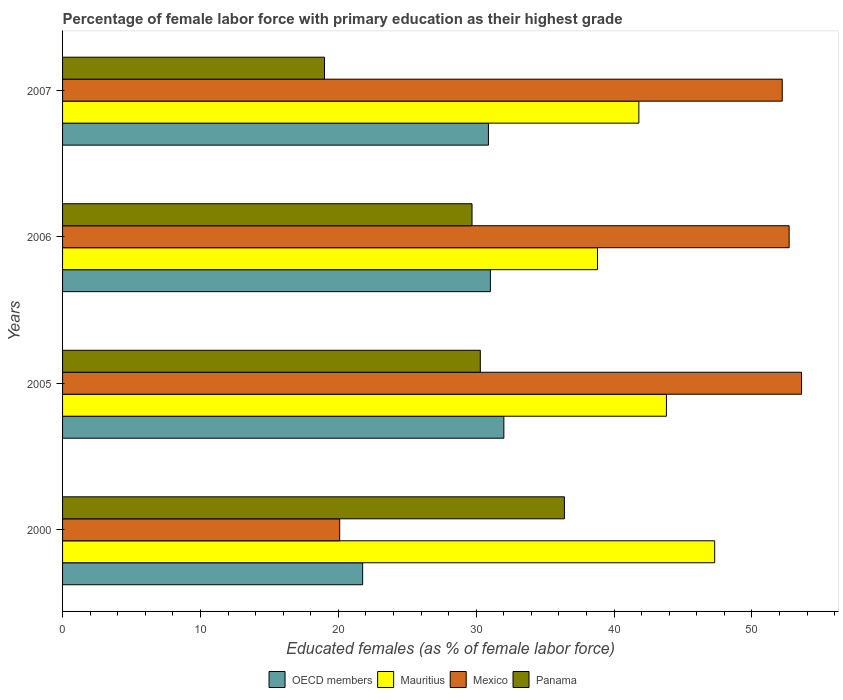How many bars are there on the 2nd tick from the top?
Your answer should be compact. 4. How many bars are there on the 1st tick from the bottom?
Provide a succinct answer. 4. What is the label of the 3rd group of bars from the top?
Ensure brevity in your answer.  2005. In how many cases, is the number of bars for a given year not equal to the number of legend labels?
Make the answer very short. 0. What is the percentage of female labor force with primary education in Mexico in 2005?
Offer a terse response. 53.6. Across all years, what is the maximum percentage of female labor force with primary education in Panama?
Keep it short and to the point. 36.4. Across all years, what is the minimum percentage of female labor force with primary education in Panama?
Keep it short and to the point. 19. In which year was the percentage of female labor force with primary education in Panama minimum?
Make the answer very short. 2007. What is the total percentage of female labor force with primary education in Mexico in the graph?
Ensure brevity in your answer.  178.6. What is the difference between the percentage of female labor force with primary education in Panama in 2005 and that in 2007?
Offer a very short reply. 11.3. What is the difference between the percentage of female labor force with primary education in OECD members in 2006 and the percentage of female labor force with primary education in Panama in 2007?
Ensure brevity in your answer.  12.03. What is the average percentage of female labor force with primary education in Panama per year?
Your answer should be very brief. 28.85. In the year 2005, what is the difference between the percentage of female labor force with primary education in OECD members and percentage of female labor force with primary education in Mauritius?
Ensure brevity in your answer.  -11.79. What is the ratio of the percentage of female labor force with primary education in Mauritius in 2006 to that in 2007?
Give a very brief answer. 0.93. Is the percentage of female labor force with primary education in Mexico in 2006 less than that in 2007?
Make the answer very short. No. Is the difference between the percentage of female labor force with primary education in OECD members in 2006 and 2007 greater than the difference between the percentage of female labor force with primary education in Mauritius in 2006 and 2007?
Your answer should be compact. Yes. What is the difference between the highest and the second highest percentage of female labor force with primary education in OECD members?
Your answer should be compact. 0.98. What is the difference between the highest and the lowest percentage of female labor force with primary education in Panama?
Offer a terse response. 17.4. Is the sum of the percentage of female labor force with primary education in OECD members in 2000 and 2007 greater than the maximum percentage of female labor force with primary education in Mexico across all years?
Provide a short and direct response. No. Is it the case that in every year, the sum of the percentage of female labor force with primary education in Panama and percentage of female labor force with primary education in OECD members is greater than the sum of percentage of female labor force with primary education in Mexico and percentage of female labor force with primary education in Mauritius?
Provide a succinct answer. No. What does the 2nd bar from the bottom in 2007 represents?
Give a very brief answer. Mauritius. How many bars are there?
Your answer should be very brief. 16. Are all the bars in the graph horizontal?
Your answer should be very brief. Yes. What is the difference between two consecutive major ticks on the X-axis?
Give a very brief answer. 10. Does the graph contain grids?
Your answer should be very brief. No. What is the title of the graph?
Offer a terse response. Percentage of female labor force with primary education as their highest grade. Does "Congo (Republic)" appear as one of the legend labels in the graph?
Your answer should be very brief. No. What is the label or title of the X-axis?
Offer a very short reply. Educated females (as % of female labor force). What is the label or title of the Y-axis?
Your answer should be compact. Years. What is the Educated females (as % of female labor force) of OECD members in 2000?
Provide a succinct answer. 21.77. What is the Educated females (as % of female labor force) in Mauritius in 2000?
Offer a very short reply. 47.3. What is the Educated females (as % of female labor force) of Mexico in 2000?
Your answer should be very brief. 20.1. What is the Educated females (as % of female labor force) in Panama in 2000?
Offer a very short reply. 36.4. What is the Educated females (as % of female labor force) in OECD members in 2005?
Keep it short and to the point. 32.01. What is the Educated females (as % of female labor force) of Mauritius in 2005?
Your response must be concise. 43.8. What is the Educated females (as % of female labor force) of Mexico in 2005?
Your response must be concise. 53.6. What is the Educated females (as % of female labor force) in Panama in 2005?
Give a very brief answer. 30.3. What is the Educated females (as % of female labor force) in OECD members in 2006?
Your response must be concise. 31.03. What is the Educated females (as % of female labor force) of Mauritius in 2006?
Provide a succinct answer. 38.8. What is the Educated females (as % of female labor force) of Mexico in 2006?
Your answer should be very brief. 52.7. What is the Educated females (as % of female labor force) in Panama in 2006?
Your answer should be very brief. 29.7. What is the Educated females (as % of female labor force) in OECD members in 2007?
Make the answer very short. 30.89. What is the Educated females (as % of female labor force) in Mauritius in 2007?
Make the answer very short. 41.8. What is the Educated females (as % of female labor force) in Mexico in 2007?
Your answer should be very brief. 52.2. What is the Educated females (as % of female labor force) of Panama in 2007?
Provide a succinct answer. 19. Across all years, what is the maximum Educated females (as % of female labor force) of OECD members?
Ensure brevity in your answer.  32.01. Across all years, what is the maximum Educated females (as % of female labor force) of Mauritius?
Offer a terse response. 47.3. Across all years, what is the maximum Educated females (as % of female labor force) in Mexico?
Offer a terse response. 53.6. Across all years, what is the maximum Educated females (as % of female labor force) in Panama?
Give a very brief answer. 36.4. Across all years, what is the minimum Educated females (as % of female labor force) of OECD members?
Your answer should be compact. 21.77. Across all years, what is the minimum Educated females (as % of female labor force) in Mauritius?
Ensure brevity in your answer.  38.8. Across all years, what is the minimum Educated females (as % of female labor force) in Mexico?
Provide a succinct answer. 20.1. What is the total Educated females (as % of female labor force) in OECD members in the graph?
Make the answer very short. 115.69. What is the total Educated females (as % of female labor force) in Mauritius in the graph?
Keep it short and to the point. 171.7. What is the total Educated females (as % of female labor force) of Mexico in the graph?
Your answer should be compact. 178.6. What is the total Educated females (as % of female labor force) in Panama in the graph?
Keep it short and to the point. 115.4. What is the difference between the Educated females (as % of female labor force) of OECD members in 2000 and that in 2005?
Your response must be concise. -10.24. What is the difference between the Educated females (as % of female labor force) of Mexico in 2000 and that in 2005?
Give a very brief answer. -33.5. What is the difference between the Educated females (as % of female labor force) in OECD members in 2000 and that in 2006?
Ensure brevity in your answer.  -9.26. What is the difference between the Educated females (as % of female labor force) in Mauritius in 2000 and that in 2006?
Make the answer very short. 8.5. What is the difference between the Educated females (as % of female labor force) in Mexico in 2000 and that in 2006?
Provide a short and direct response. -32.6. What is the difference between the Educated females (as % of female labor force) of Panama in 2000 and that in 2006?
Give a very brief answer. 6.7. What is the difference between the Educated females (as % of female labor force) of OECD members in 2000 and that in 2007?
Offer a terse response. -9.12. What is the difference between the Educated females (as % of female labor force) of Mauritius in 2000 and that in 2007?
Make the answer very short. 5.5. What is the difference between the Educated females (as % of female labor force) of Mexico in 2000 and that in 2007?
Provide a succinct answer. -32.1. What is the difference between the Educated females (as % of female labor force) of Panama in 2000 and that in 2007?
Your response must be concise. 17.4. What is the difference between the Educated females (as % of female labor force) in OECD members in 2005 and that in 2006?
Keep it short and to the point. 0.98. What is the difference between the Educated females (as % of female labor force) of Mauritius in 2005 and that in 2006?
Provide a succinct answer. 5. What is the difference between the Educated females (as % of female labor force) in OECD members in 2005 and that in 2007?
Your answer should be compact. 1.12. What is the difference between the Educated females (as % of female labor force) of Mauritius in 2005 and that in 2007?
Offer a terse response. 2. What is the difference between the Educated females (as % of female labor force) in Panama in 2005 and that in 2007?
Your response must be concise. 11.3. What is the difference between the Educated females (as % of female labor force) of OECD members in 2006 and that in 2007?
Offer a terse response. 0.14. What is the difference between the Educated females (as % of female labor force) of OECD members in 2000 and the Educated females (as % of female labor force) of Mauritius in 2005?
Keep it short and to the point. -22.03. What is the difference between the Educated females (as % of female labor force) in OECD members in 2000 and the Educated females (as % of female labor force) in Mexico in 2005?
Offer a terse response. -31.83. What is the difference between the Educated females (as % of female labor force) in OECD members in 2000 and the Educated females (as % of female labor force) in Panama in 2005?
Offer a terse response. -8.53. What is the difference between the Educated females (as % of female labor force) of Mauritius in 2000 and the Educated females (as % of female labor force) of Mexico in 2005?
Your response must be concise. -6.3. What is the difference between the Educated females (as % of female labor force) of OECD members in 2000 and the Educated females (as % of female labor force) of Mauritius in 2006?
Offer a very short reply. -17.03. What is the difference between the Educated females (as % of female labor force) in OECD members in 2000 and the Educated females (as % of female labor force) in Mexico in 2006?
Offer a terse response. -30.93. What is the difference between the Educated females (as % of female labor force) in OECD members in 2000 and the Educated females (as % of female labor force) in Panama in 2006?
Your answer should be compact. -7.93. What is the difference between the Educated females (as % of female labor force) of Mauritius in 2000 and the Educated females (as % of female labor force) of Mexico in 2006?
Your answer should be compact. -5.4. What is the difference between the Educated females (as % of female labor force) of OECD members in 2000 and the Educated females (as % of female labor force) of Mauritius in 2007?
Provide a succinct answer. -20.03. What is the difference between the Educated females (as % of female labor force) in OECD members in 2000 and the Educated females (as % of female labor force) in Mexico in 2007?
Your answer should be very brief. -30.43. What is the difference between the Educated females (as % of female labor force) of OECD members in 2000 and the Educated females (as % of female labor force) of Panama in 2007?
Keep it short and to the point. 2.77. What is the difference between the Educated females (as % of female labor force) in Mauritius in 2000 and the Educated females (as % of female labor force) in Panama in 2007?
Give a very brief answer. 28.3. What is the difference between the Educated females (as % of female labor force) in Mexico in 2000 and the Educated females (as % of female labor force) in Panama in 2007?
Your answer should be very brief. 1.1. What is the difference between the Educated females (as % of female labor force) in OECD members in 2005 and the Educated females (as % of female labor force) in Mauritius in 2006?
Provide a succinct answer. -6.79. What is the difference between the Educated females (as % of female labor force) in OECD members in 2005 and the Educated females (as % of female labor force) in Mexico in 2006?
Offer a very short reply. -20.69. What is the difference between the Educated females (as % of female labor force) in OECD members in 2005 and the Educated females (as % of female labor force) in Panama in 2006?
Your response must be concise. 2.31. What is the difference between the Educated females (as % of female labor force) in Mauritius in 2005 and the Educated females (as % of female labor force) in Mexico in 2006?
Your answer should be very brief. -8.9. What is the difference between the Educated females (as % of female labor force) in Mexico in 2005 and the Educated females (as % of female labor force) in Panama in 2006?
Ensure brevity in your answer.  23.9. What is the difference between the Educated females (as % of female labor force) of OECD members in 2005 and the Educated females (as % of female labor force) of Mauritius in 2007?
Offer a terse response. -9.79. What is the difference between the Educated females (as % of female labor force) of OECD members in 2005 and the Educated females (as % of female labor force) of Mexico in 2007?
Offer a terse response. -20.19. What is the difference between the Educated females (as % of female labor force) of OECD members in 2005 and the Educated females (as % of female labor force) of Panama in 2007?
Offer a very short reply. 13.01. What is the difference between the Educated females (as % of female labor force) of Mauritius in 2005 and the Educated females (as % of female labor force) of Panama in 2007?
Offer a terse response. 24.8. What is the difference between the Educated females (as % of female labor force) of Mexico in 2005 and the Educated females (as % of female labor force) of Panama in 2007?
Give a very brief answer. 34.6. What is the difference between the Educated females (as % of female labor force) in OECD members in 2006 and the Educated females (as % of female labor force) in Mauritius in 2007?
Provide a short and direct response. -10.77. What is the difference between the Educated females (as % of female labor force) of OECD members in 2006 and the Educated females (as % of female labor force) of Mexico in 2007?
Your answer should be very brief. -21.17. What is the difference between the Educated females (as % of female labor force) of OECD members in 2006 and the Educated females (as % of female labor force) of Panama in 2007?
Give a very brief answer. 12.03. What is the difference between the Educated females (as % of female labor force) in Mauritius in 2006 and the Educated females (as % of female labor force) in Mexico in 2007?
Give a very brief answer. -13.4. What is the difference between the Educated females (as % of female labor force) in Mauritius in 2006 and the Educated females (as % of female labor force) in Panama in 2007?
Make the answer very short. 19.8. What is the difference between the Educated females (as % of female labor force) of Mexico in 2006 and the Educated females (as % of female labor force) of Panama in 2007?
Offer a terse response. 33.7. What is the average Educated females (as % of female labor force) in OECD members per year?
Keep it short and to the point. 28.92. What is the average Educated females (as % of female labor force) of Mauritius per year?
Your answer should be compact. 42.92. What is the average Educated females (as % of female labor force) of Mexico per year?
Offer a very short reply. 44.65. What is the average Educated females (as % of female labor force) in Panama per year?
Offer a terse response. 28.85. In the year 2000, what is the difference between the Educated females (as % of female labor force) of OECD members and Educated females (as % of female labor force) of Mauritius?
Ensure brevity in your answer.  -25.53. In the year 2000, what is the difference between the Educated females (as % of female labor force) of OECD members and Educated females (as % of female labor force) of Mexico?
Provide a short and direct response. 1.67. In the year 2000, what is the difference between the Educated females (as % of female labor force) of OECD members and Educated females (as % of female labor force) of Panama?
Offer a terse response. -14.63. In the year 2000, what is the difference between the Educated females (as % of female labor force) in Mauritius and Educated females (as % of female labor force) in Mexico?
Make the answer very short. 27.2. In the year 2000, what is the difference between the Educated females (as % of female labor force) in Mexico and Educated females (as % of female labor force) in Panama?
Offer a very short reply. -16.3. In the year 2005, what is the difference between the Educated females (as % of female labor force) of OECD members and Educated females (as % of female labor force) of Mauritius?
Provide a short and direct response. -11.79. In the year 2005, what is the difference between the Educated females (as % of female labor force) in OECD members and Educated females (as % of female labor force) in Mexico?
Offer a terse response. -21.59. In the year 2005, what is the difference between the Educated females (as % of female labor force) in OECD members and Educated females (as % of female labor force) in Panama?
Keep it short and to the point. 1.71. In the year 2005, what is the difference between the Educated females (as % of female labor force) of Mauritius and Educated females (as % of female labor force) of Panama?
Provide a succinct answer. 13.5. In the year 2005, what is the difference between the Educated females (as % of female labor force) in Mexico and Educated females (as % of female labor force) in Panama?
Make the answer very short. 23.3. In the year 2006, what is the difference between the Educated females (as % of female labor force) in OECD members and Educated females (as % of female labor force) in Mauritius?
Your answer should be compact. -7.77. In the year 2006, what is the difference between the Educated females (as % of female labor force) in OECD members and Educated females (as % of female labor force) in Mexico?
Make the answer very short. -21.67. In the year 2006, what is the difference between the Educated females (as % of female labor force) in OECD members and Educated females (as % of female labor force) in Panama?
Make the answer very short. 1.33. In the year 2006, what is the difference between the Educated females (as % of female labor force) in Mauritius and Educated females (as % of female labor force) in Mexico?
Your response must be concise. -13.9. In the year 2006, what is the difference between the Educated females (as % of female labor force) in Mauritius and Educated females (as % of female labor force) in Panama?
Give a very brief answer. 9.1. In the year 2007, what is the difference between the Educated females (as % of female labor force) of OECD members and Educated females (as % of female labor force) of Mauritius?
Provide a succinct answer. -10.91. In the year 2007, what is the difference between the Educated females (as % of female labor force) of OECD members and Educated females (as % of female labor force) of Mexico?
Ensure brevity in your answer.  -21.31. In the year 2007, what is the difference between the Educated females (as % of female labor force) in OECD members and Educated females (as % of female labor force) in Panama?
Keep it short and to the point. 11.89. In the year 2007, what is the difference between the Educated females (as % of female labor force) in Mauritius and Educated females (as % of female labor force) in Panama?
Keep it short and to the point. 22.8. In the year 2007, what is the difference between the Educated females (as % of female labor force) in Mexico and Educated females (as % of female labor force) in Panama?
Your answer should be very brief. 33.2. What is the ratio of the Educated females (as % of female labor force) of OECD members in 2000 to that in 2005?
Ensure brevity in your answer.  0.68. What is the ratio of the Educated females (as % of female labor force) of Mauritius in 2000 to that in 2005?
Offer a very short reply. 1.08. What is the ratio of the Educated females (as % of female labor force) in Panama in 2000 to that in 2005?
Offer a terse response. 1.2. What is the ratio of the Educated females (as % of female labor force) in OECD members in 2000 to that in 2006?
Ensure brevity in your answer.  0.7. What is the ratio of the Educated females (as % of female labor force) in Mauritius in 2000 to that in 2006?
Your answer should be compact. 1.22. What is the ratio of the Educated females (as % of female labor force) of Mexico in 2000 to that in 2006?
Keep it short and to the point. 0.38. What is the ratio of the Educated females (as % of female labor force) of Panama in 2000 to that in 2006?
Provide a succinct answer. 1.23. What is the ratio of the Educated females (as % of female labor force) in OECD members in 2000 to that in 2007?
Make the answer very short. 0.7. What is the ratio of the Educated females (as % of female labor force) of Mauritius in 2000 to that in 2007?
Offer a terse response. 1.13. What is the ratio of the Educated females (as % of female labor force) of Mexico in 2000 to that in 2007?
Provide a short and direct response. 0.39. What is the ratio of the Educated females (as % of female labor force) in Panama in 2000 to that in 2007?
Give a very brief answer. 1.92. What is the ratio of the Educated females (as % of female labor force) in OECD members in 2005 to that in 2006?
Provide a succinct answer. 1.03. What is the ratio of the Educated females (as % of female labor force) of Mauritius in 2005 to that in 2006?
Make the answer very short. 1.13. What is the ratio of the Educated females (as % of female labor force) in Mexico in 2005 to that in 2006?
Make the answer very short. 1.02. What is the ratio of the Educated females (as % of female labor force) of Panama in 2005 to that in 2006?
Make the answer very short. 1.02. What is the ratio of the Educated females (as % of female labor force) in OECD members in 2005 to that in 2007?
Offer a terse response. 1.04. What is the ratio of the Educated females (as % of female labor force) in Mauritius in 2005 to that in 2007?
Provide a succinct answer. 1.05. What is the ratio of the Educated females (as % of female labor force) in Mexico in 2005 to that in 2007?
Your answer should be compact. 1.03. What is the ratio of the Educated females (as % of female labor force) of Panama in 2005 to that in 2007?
Your answer should be compact. 1.59. What is the ratio of the Educated females (as % of female labor force) in OECD members in 2006 to that in 2007?
Your answer should be very brief. 1. What is the ratio of the Educated females (as % of female labor force) of Mauritius in 2006 to that in 2007?
Offer a terse response. 0.93. What is the ratio of the Educated females (as % of female labor force) in Mexico in 2006 to that in 2007?
Your response must be concise. 1.01. What is the ratio of the Educated females (as % of female labor force) of Panama in 2006 to that in 2007?
Make the answer very short. 1.56. What is the difference between the highest and the second highest Educated females (as % of female labor force) of OECD members?
Your answer should be very brief. 0.98. What is the difference between the highest and the second highest Educated females (as % of female labor force) of Mauritius?
Offer a very short reply. 3.5. What is the difference between the highest and the second highest Educated females (as % of female labor force) of Mexico?
Your answer should be compact. 0.9. What is the difference between the highest and the lowest Educated females (as % of female labor force) of OECD members?
Make the answer very short. 10.24. What is the difference between the highest and the lowest Educated females (as % of female labor force) of Mexico?
Offer a terse response. 33.5. What is the difference between the highest and the lowest Educated females (as % of female labor force) of Panama?
Your response must be concise. 17.4. 